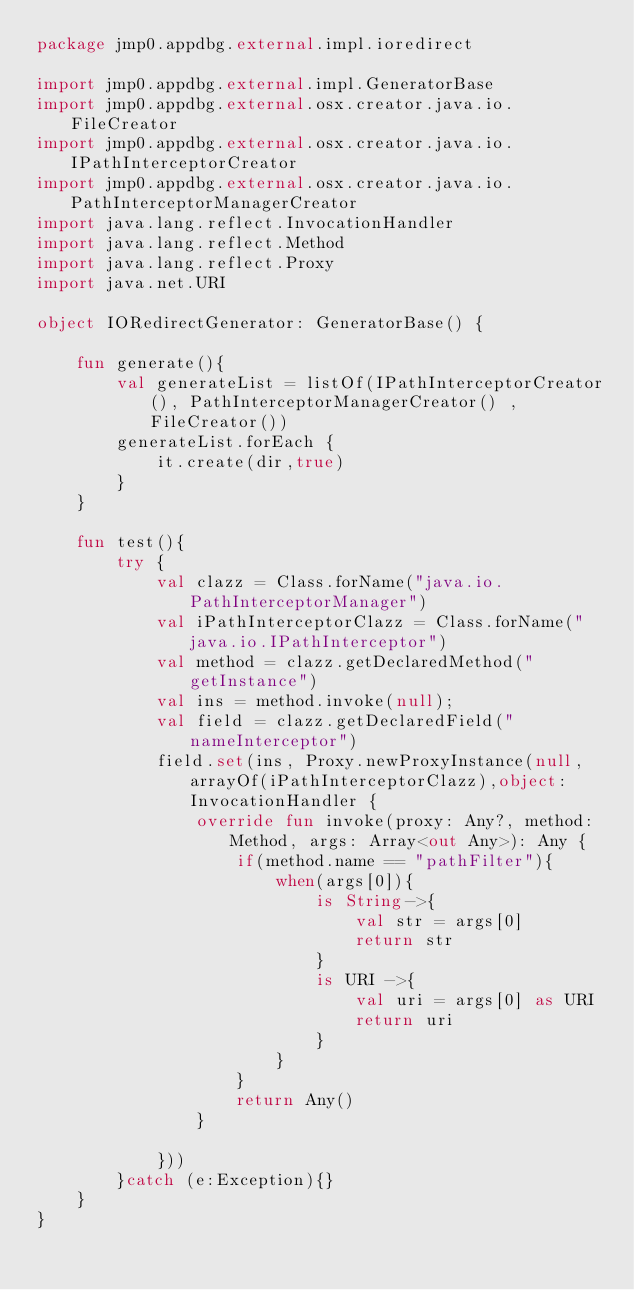<code> <loc_0><loc_0><loc_500><loc_500><_Kotlin_>package jmp0.appdbg.external.impl.ioredirect

import jmp0.appdbg.external.impl.GeneratorBase
import jmp0.appdbg.external.osx.creator.java.io.FileCreator
import jmp0.appdbg.external.osx.creator.java.io.IPathInterceptorCreator
import jmp0.appdbg.external.osx.creator.java.io.PathInterceptorManagerCreator
import java.lang.reflect.InvocationHandler
import java.lang.reflect.Method
import java.lang.reflect.Proxy
import java.net.URI

object IORedirectGenerator: GeneratorBase() {

    fun generate(){
        val generateList = listOf(IPathInterceptorCreator(), PathInterceptorManagerCreator() , FileCreator())
        generateList.forEach {
            it.create(dir,true)
        }
    }

    fun test(){
        try {
            val clazz = Class.forName("java.io.PathInterceptorManager")
            val iPathInterceptorClazz = Class.forName("java.io.IPathInterceptor")
            val method = clazz.getDeclaredMethod("getInstance")
            val ins = method.invoke(null);
            val field = clazz.getDeclaredField("nameInterceptor")
            field.set(ins, Proxy.newProxyInstance(null, arrayOf(iPathInterceptorClazz),object: InvocationHandler {
                override fun invoke(proxy: Any?, method: Method, args: Array<out Any>): Any {
                    if(method.name == "pathFilter"){
                        when(args[0]){
                            is String->{
                                val str = args[0]
                                return str
                            }
                            is URI ->{
                                val uri = args[0] as URI
                                return uri
                            }
                        }
                    }
                    return Any()
                }

            }))
        }catch (e:Exception){}
    }
}</code> 